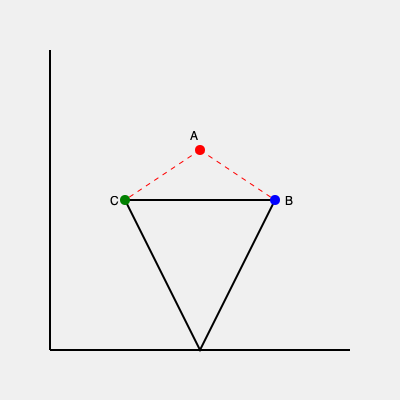In a crucial scene, you need to capture a triangular sculpture from above. The sculpture's base is an equilateral triangle with side length 10 meters. Your camera is positioned 5 meters directly above the center of the triangle (point A). If you want to include two vertices of the triangle (points B and C) at the edges of your frame, what approximate angle should your camera's field of view be set to? To solve this problem, we'll follow these steps:

1) First, we need to understand the geometry of the situation. We have an equilateral triangle with side length 10m, and the camera is 5m above the center.

2) In an equilateral triangle, the distance from the center to any vertex is $\frac{\sqrt{3}}{3}$ times the side length. So this distance is:

   $\frac{\sqrt{3}}{3} \cdot 10 = \frac{10\sqrt{3}}{3}$ meters

3) Now we have a right triangle formed by the camera position, the center of the base triangle, and either vertex B or C. The base of this right triangle is $\frac{10\sqrt{3}}{3}$ and the height is 5.

4) We can find the angle using the tangent function:

   $\tan(\frac{\theta}{2}) = \frac{\text{opposite}}{\text{adjacent}} = \frac{10\sqrt{3}/3}{5} = \frac{2\sqrt{3}}{3}$

5) To get $\theta$, we use the arctangent and multiply by 2:

   $\theta = 2 \cdot \arctan(\frac{2\sqrt{3}}{3})$

6) Calculating this gives us approximately 109.47 degrees.

7) This is the field of view angle that will just capture two vertices of the triangle at the edges of the frame.
Answer: 109.47 degrees 